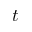<formula> <loc_0><loc_0><loc_500><loc_500>{ t }</formula> 